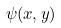<formula> <loc_0><loc_0><loc_500><loc_500>\psi ( x , y )</formula> 